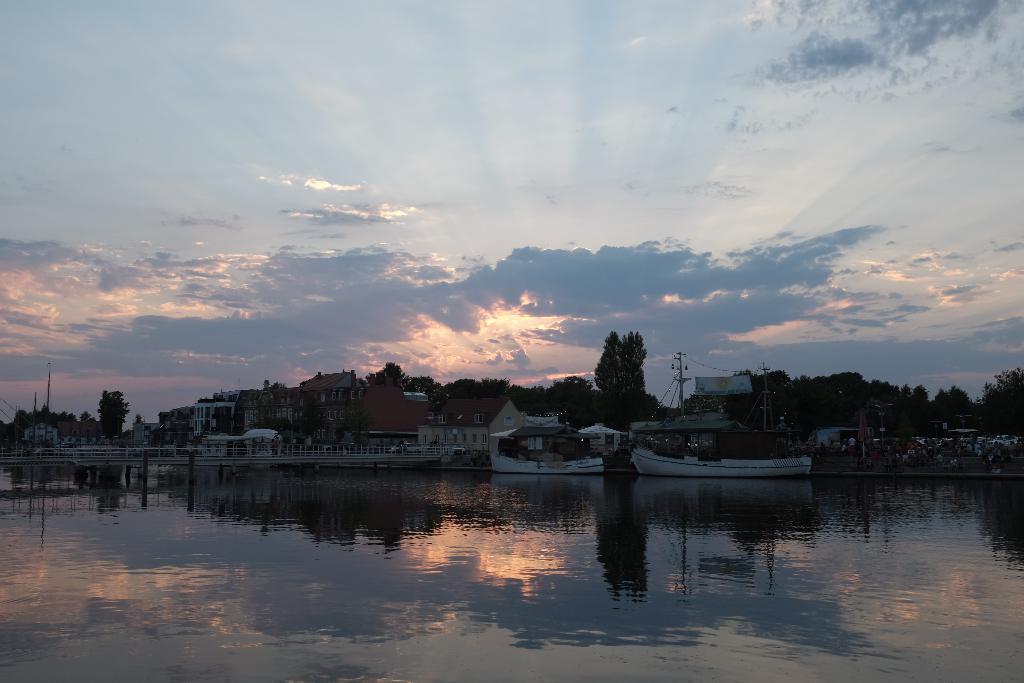Can you describe this image briefly? There are boats on the water. In the background, there are trees and buildings on the ground and there are clouds in the blue sky. 